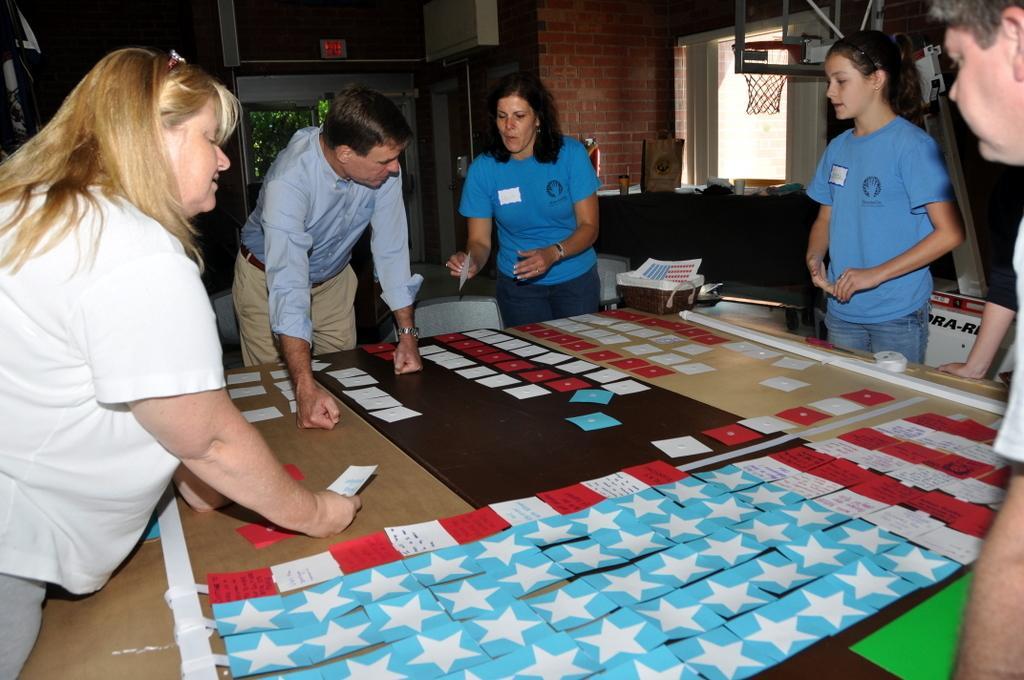How would you summarize this image in a sentence or two? As we can see in the image there is a brick wall, window, net and few people standing around table. On table there are papers. 